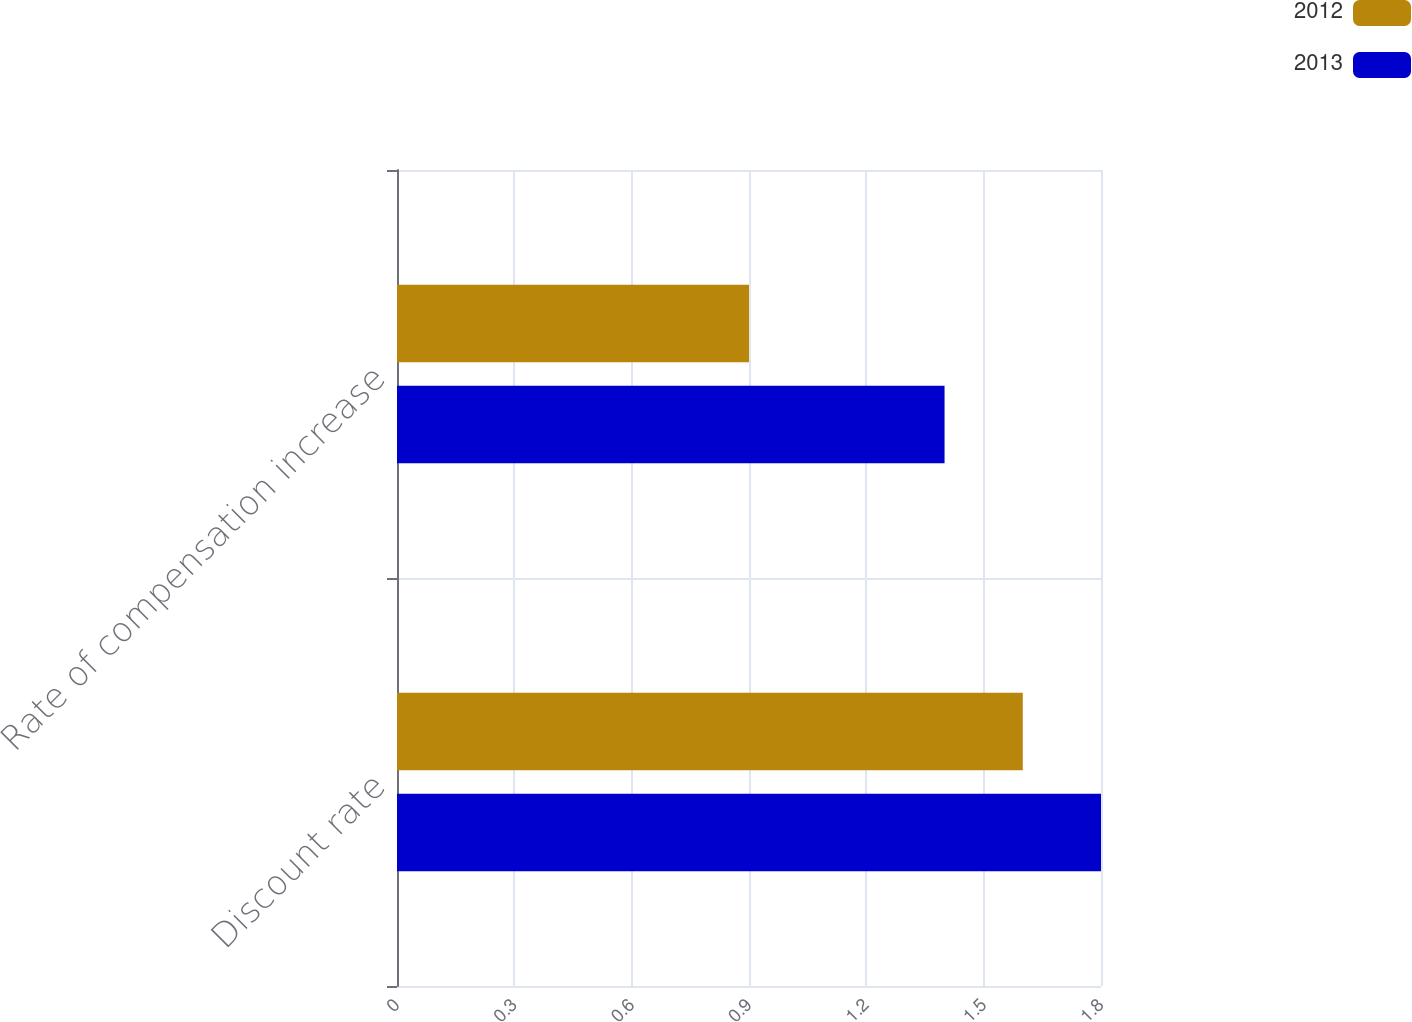Convert chart. <chart><loc_0><loc_0><loc_500><loc_500><stacked_bar_chart><ecel><fcel>Discount rate<fcel>Rate of compensation increase<nl><fcel>2012<fcel>1.6<fcel>0.9<nl><fcel>2013<fcel>1.8<fcel>1.4<nl></chart> 